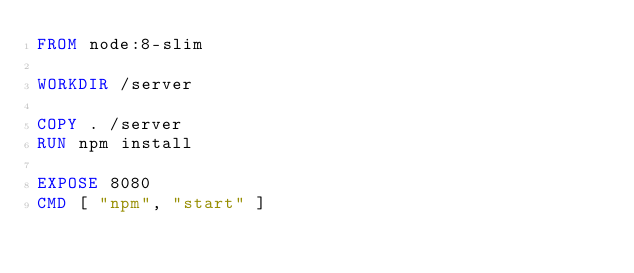Convert code to text. <code><loc_0><loc_0><loc_500><loc_500><_Dockerfile_>FROM node:8-slim

WORKDIR /server

COPY . /server
RUN npm install

EXPOSE 8080
CMD [ "npm", "start" ]
</code> 